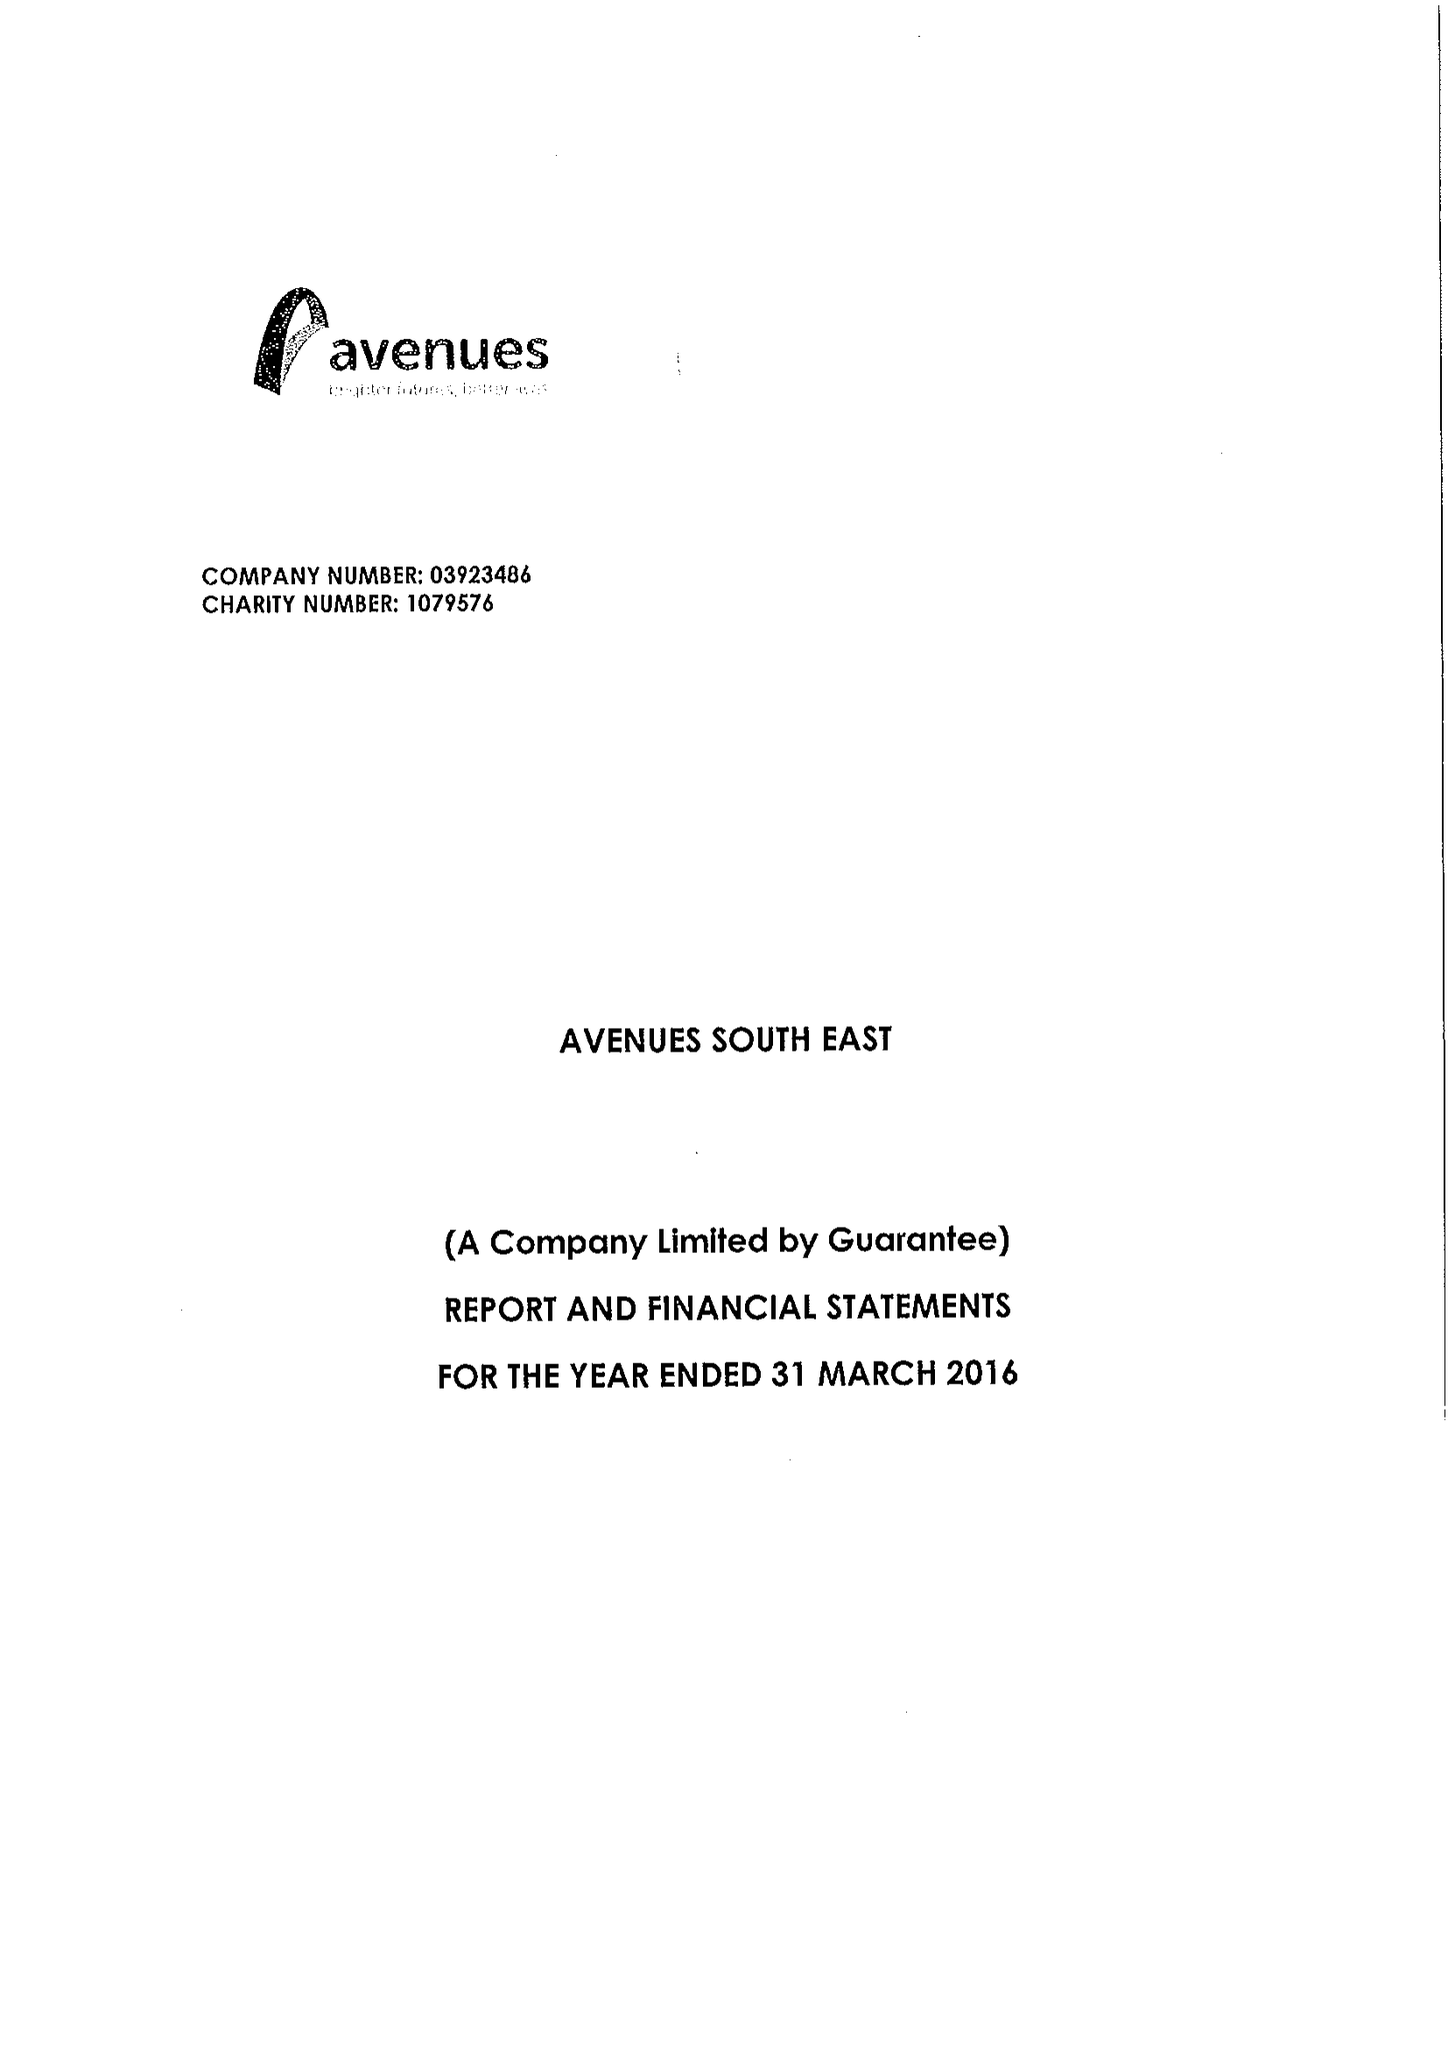What is the value for the address__postcode?
Answer the question using a single word or phrase. DA14 5TA 